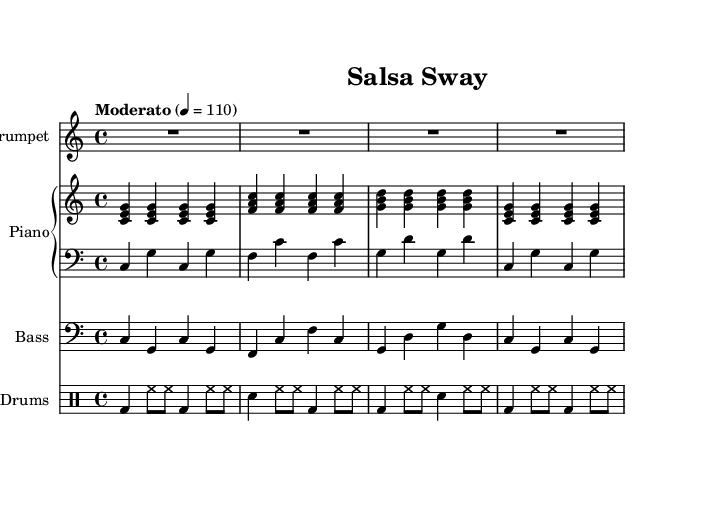What is the key signature of this music? The key signature is indicated at the beginning of the score, showing no sharps or flats, which corresponds to C major.
Answer: C major What is the time signature of this music? The time signature, found at the beginning of the score, indicates that there are four beats in each measure, represented as 4/4.
Answer: 4/4 What is the tempo marking for this piece? The tempo marking specifies the speed of the music; here it states "Moderato" with a metronome marking of 110 beats per minute.
Answer: Moderato, 110 How many measures are present in the melody section? Counting the distinct groupings of notes from the melody line reveals a total of four measures indicated by the spacings and bars.
Answer: 4 What instruments are featured in this score? The instruments are listed at the beginning of each staff and include Trumpet, Piano, Bass, and Drums.
Answer: Trumpet, Piano, Bass, Drums What is the pattern of the bass voice in the first measure? The bass voice consists of a specific sequence of notes: C, G, C, G, which follows the established rhythm in that measure.
Answer: C, G, C, G How does the rhythm contribute to the Latin jazz fusion style? The combination of the steady bassline, syncopated drum patterns, and lively melodies in a moderate tempo creates a rhythmic complexity typical of Latin jazz fusion, promoting movement and enhancing balance.
Answer: Rhythmic complexity typical of Latin jazz fusion 